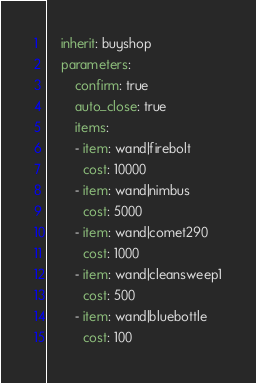<code> <loc_0><loc_0><loc_500><loc_500><_YAML_>    inherit: buyshop
    parameters:
        confirm: true
        auto_close: true
        items:
        - item: wand|firebolt
          cost: 10000
        - item: wand|nimbus
          cost: 5000
        - item: wand|comet290
          cost: 1000
        - item: wand|cleansweep1
          cost: 500
        - item: wand|bluebottle
          cost: 100

</code> 